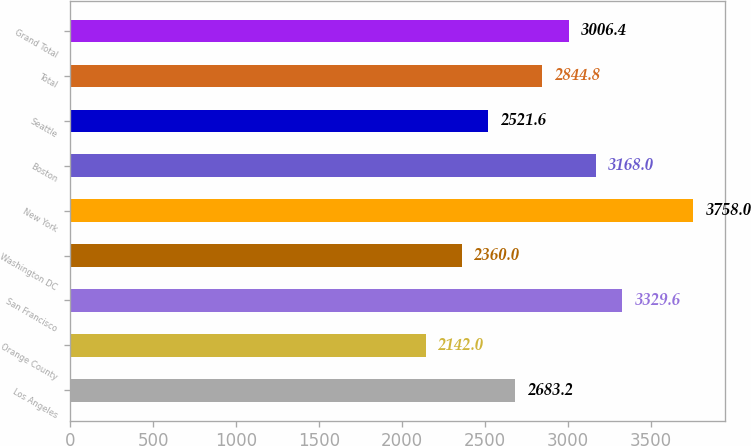Convert chart to OTSL. <chart><loc_0><loc_0><loc_500><loc_500><bar_chart><fcel>Los Angeles<fcel>Orange County<fcel>San Francisco<fcel>Washington DC<fcel>New York<fcel>Boston<fcel>Seattle<fcel>Total<fcel>Grand Total<nl><fcel>2683.2<fcel>2142<fcel>3329.6<fcel>2360<fcel>3758<fcel>3168<fcel>2521.6<fcel>2844.8<fcel>3006.4<nl></chart> 